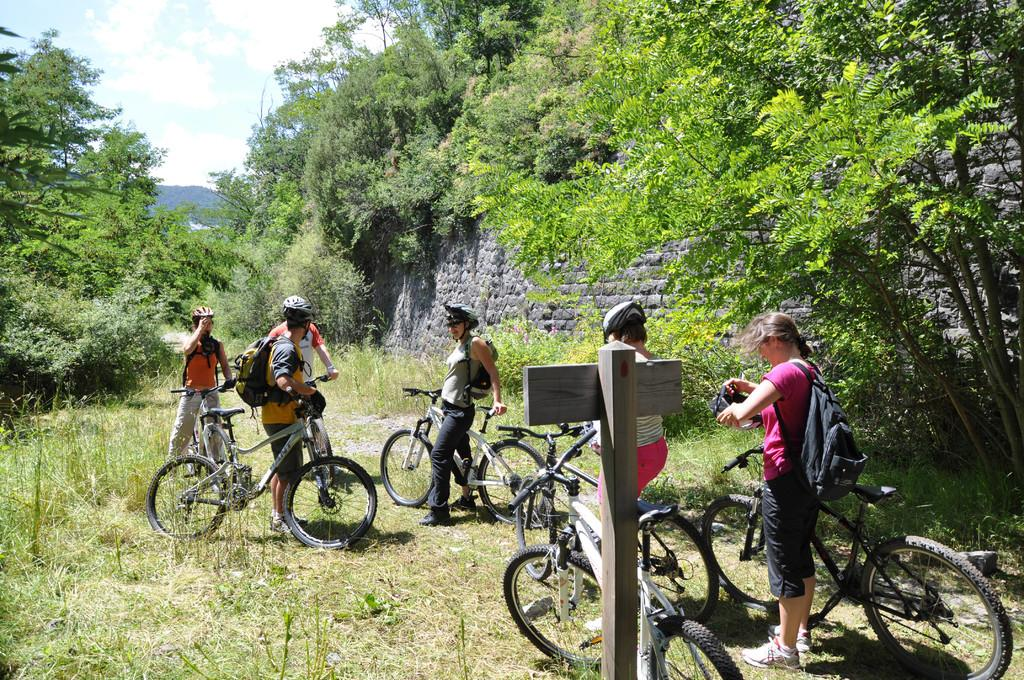How many persons are in the image? There is a group of persons in the image. What are the persons doing in the image? The persons are on cycles. What can be seen in the background of the image? There are trees, plants, a wall, a hill, and the sky visible in the background of the image. What is the condition of the sky in the image? The sky is visible in the background of the image, and there are clouds in the sky. What type of powder is being used by the persons on the cycles in the image? There is no indication in the image that the persons on the cycles are using any powder. How does the stomach of the hill affect the persons on the cycles in the image? The hill in the background of the image does not have a stomach, and it does not affect the persons on the cycles in any way. 